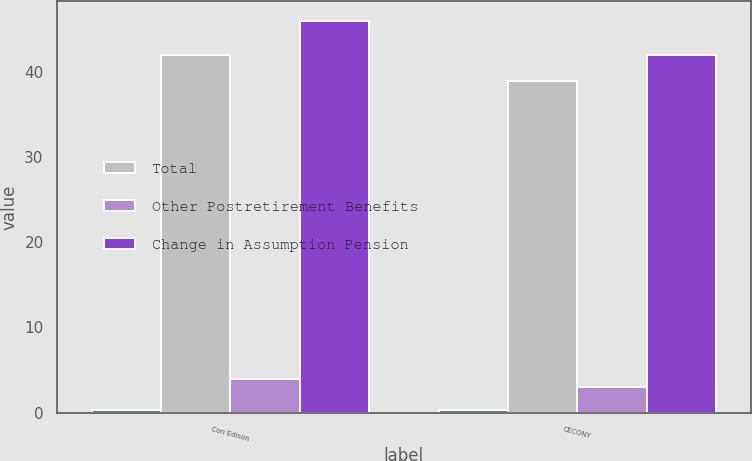<chart> <loc_0><loc_0><loc_500><loc_500><stacked_bar_chart><ecel><fcel>Con Edison<fcel>CECONY<nl><fcel>nan<fcel>0.25<fcel>0.25<nl><fcel>Total<fcel>42<fcel>39<nl><fcel>Other Postretirement Benefits<fcel>4<fcel>3<nl><fcel>Change in Assumption Pension<fcel>46<fcel>42<nl></chart> 